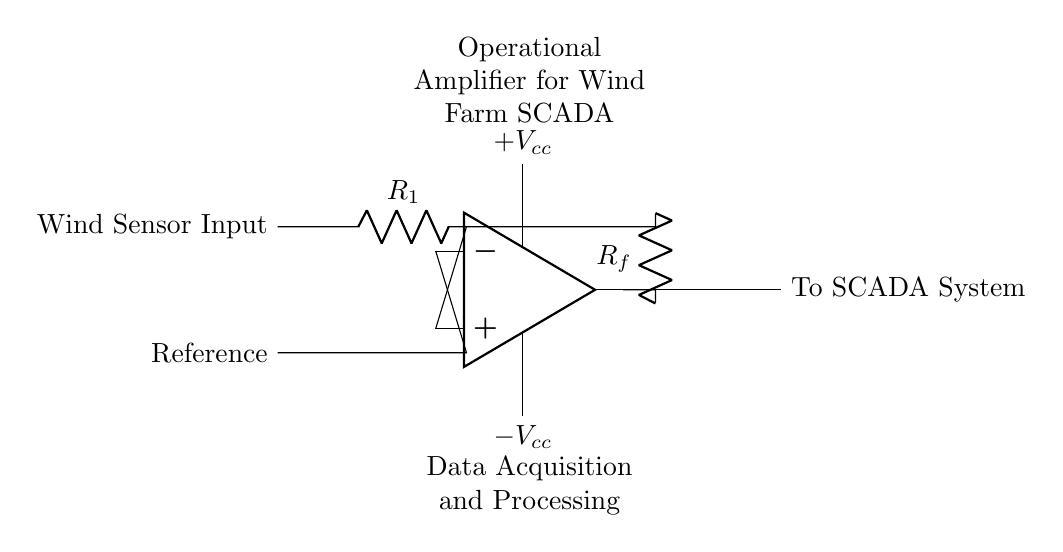What is the input connection for this op-amp? The input connection for the operational amplifier is shown on the left side, where the wind sensor input and the reference input connect to the non-inverting and inverting terminals, respectively.
Answer: Wind Sensor Input and Reference What does the feedback resistor represent? The feedback resistor, labeled as Rf, connects the output of the op-amp back to the inverting input. This creates a feedback loop which helps regulate the gain of the amplifier.
Answer: Feedback loop What is the purpose of the resistors R1 and Rf in this circuit? Resistor R1 acts as an input resistor for the wind sensor signal, while resistor Rf is used for feedback, determining the gain of the amplifier. Together, they define how the op-amp processes the input.
Answer: Input and feedback gain What is the power supply voltage indicated for this operational amplifier? The circuit diagram indicates that the operational amplifier is powered by a dual power supply, represented by +Vcc and -Vcc, but does not provide specific numeric values for these voltages.
Answer: Positive and negative power supplies Why is the operational amplifier used in the wind farm SCADA system? The operational amplifier is employed in the SCADA system for amplifying the low voltage signals from wind sensors, making them suitable for further processing and monitoring.
Answer: Amplification of signals What is the significance of the output labeled "To SCADA System"? The output from the op-amp feeds directly into the SCADA system, meaning it transmits the processed signal, which provides essential data for monitoring and controlling the wind farm operations efficiently.
Answer: Processed signal transmission 